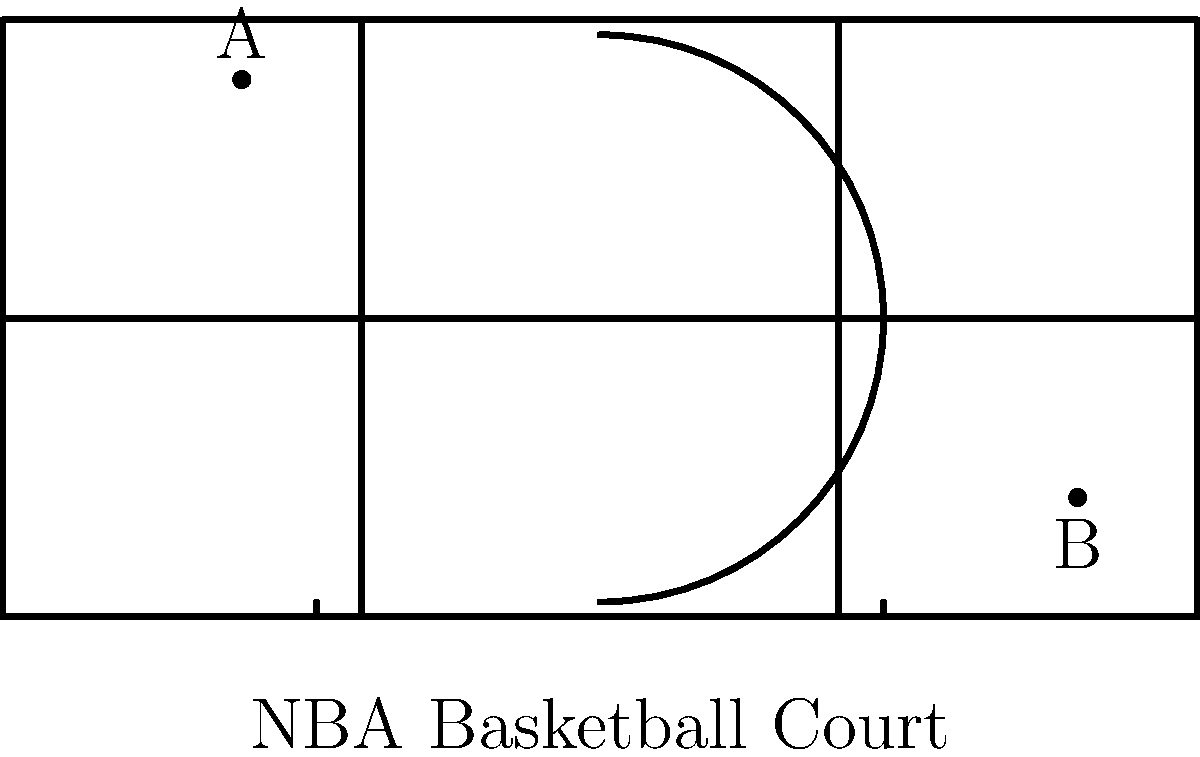On an NBA basketball court, point A is located at (-30, 20) near the three-point line, and point B is at (40, -15) in the opposite corner. As a sports commentator, you need to analyze the path of a potential long pass between these two points. Calculate the slope of the line connecting points A and B to determine the steepness of this pass. Round your answer to two decimal places. To find the slope of the line connecting points A and B, we'll use the slope formula:

$$ \text{slope} = \frac{y_2 - y_1}{x_2 - x_1} $$

Where $(x_1, y_1)$ is the coordinates of point A, and $(x_2, y_2)$ is the coordinates of point B.

Step 1: Identify the coordinates
Point A: $(-30, 20)$
Point B: $(40, -15)$

Step 2: Plug the values into the slope formula
$$ \text{slope} = \frac{-15 - 20}{40 - (-30)} $$

Step 3: Simplify the numerator and denominator
$$ \text{slope} = \frac{-35}{70} $$

Step 4: Divide and round to two decimal places
$$ \text{slope} = -0.5 $$

The negative slope indicates that the line is descending from left to right, which makes sense given the positions of points A and B on the court.
Answer: -0.50 